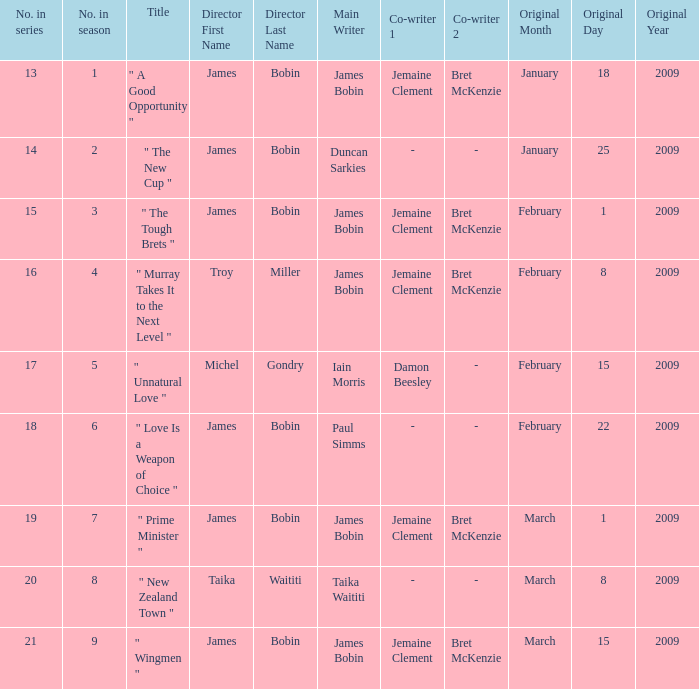Could you parse the entire table as a dict? {'header': ['No. in series', 'No. in season', 'Title', 'Director First Name', 'Director Last Name', 'Main Writer', 'Co-writer 1', 'Co-writer 2', 'Original Month', 'Original Day', 'Original Year'], 'rows': [['13', '1', '" A Good Opportunity "', 'James', 'Bobin', 'James Bobin', 'Jemaine Clement', 'Bret McKenzie', 'January', '18', '2009'], ['14', '2', '" The New Cup "', 'James', 'Bobin', 'Duncan Sarkies', '-', '-', 'January', '25', '2009'], ['15', '3', '" The Tough Brets "', 'James', 'Bobin', 'James Bobin', 'Jemaine Clement', 'Bret McKenzie', 'February', '1', '2009'], ['16', '4', '" Murray Takes It to the Next Level "', 'Troy', 'Miller', 'James Bobin', 'Jemaine Clement', 'Bret McKenzie', 'February', '8', '2009'], ['17', '5', '" Unnatural Love "', 'Michel', 'Gondry', 'Iain Morris', 'Damon Beesley', '-', 'February', '15', '2009'], ['18', '6', '" Love Is a Weapon of Choice "', 'James', 'Bobin', 'Paul Simms', '-', '-', 'February', '22', '2009'], ['19', '7', '" Prime Minister "', 'James', 'Bobin', 'James Bobin', 'Jemaine Clement', 'Bret McKenzie', 'March', '1', '2009'], ['20', '8', '" New Zealand Town "', 'Taika', 'Waititi', 'Taika Waititi', '-', '-', 'March', '8', '2009'], ['21', '9', '" Wingmen "', 'James', 'Bobin', 'James Bobin', 'Jemaine Clement', 'Bret McKenzie', 'March', '15', '2009']]} What is the initial airing date of the episode written by iain morris and damon beesley? February15,2009. 